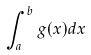<formula> <loc_0><loc_0><loc_500><loc_500>\int _ { a } ^ { b } g ( x ) d x</formula> 